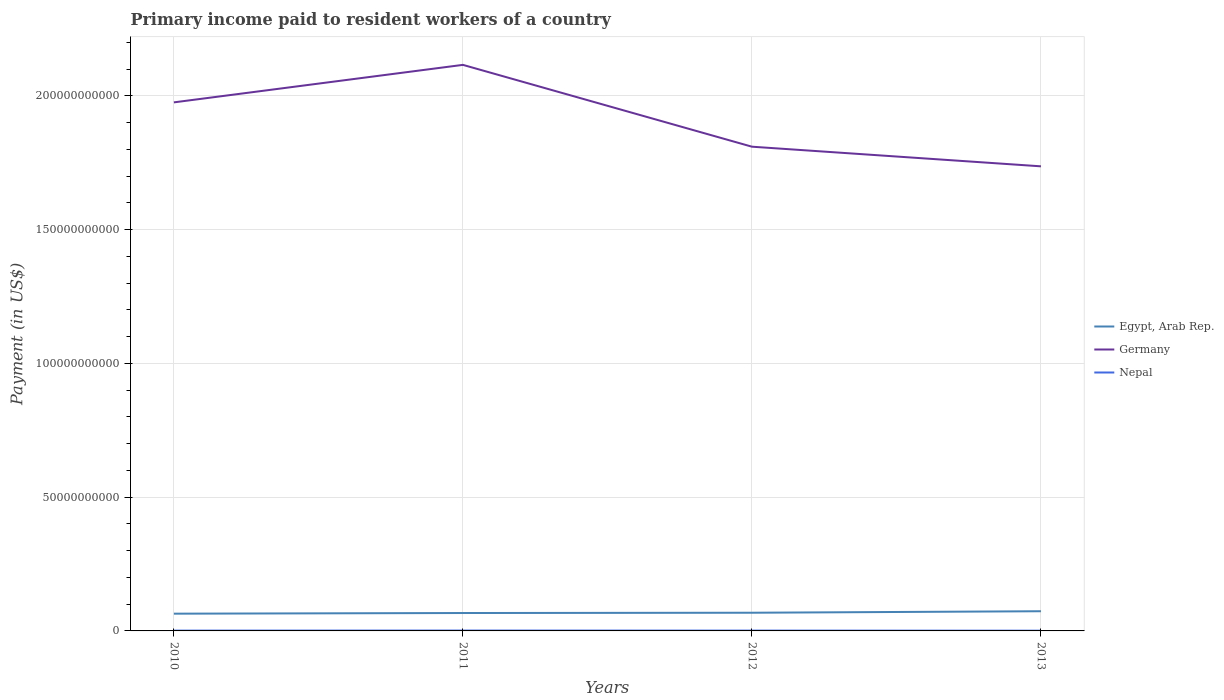How many different coloured lines are there?
Ensure brevity in your answer.  3. Across all years, what is the maximum amount paid to workers in Nepal?
Give a very brief answer. 9.06e+07. What is the total amount paid to workers in Egypt, Arab Rep. in the graph?
Provide a short and direct response. -1.01e+08. What is the difference between the highest and the second highest amount paid to workers in Egypt, Arab Rep.?
Give a very brief answer. 9.14e+08. What is the difference between the highest and the lowest amount paid to workers in Egypt, Arab Rep.?
Your answer should be very brief. 1. How many lines are there?
Keep it short and to the point. 3. What is the difference between two consecutive major ticks on the Y-axis?
Offer a terse response. 5.00e+1. Are the values on the major ticks of Y-axis written in scientific E-notation?
Provide a short and direct response. No. Does the graph contain grids?
Keep it short and to the point. Yes. Where does the legend appear in the graph?
Your response must be concise. Center right. What is the title of the graph?
Offer a very short reply. Primary income paid to resident workers of a country. Does "Namibia" appear as one of the legend labels in the graph?
Make the answer very short. No. What is the label or title of the X-axis?
Provide a succinct answer. Years. What is the label or title of the Y-axis?
Ensure brevity in your answer.  Payment (in US$). What is the Payment (in US$) in Egypt, Arab Rep. in 2010?
Offer a terse response. 6.45e+09. What is the Payment (in US$) in Germany in 2010?
Give a very brief answer. 1.98e+11. What is the Payment (in US$) in Nepal in 2010?
Provide a succinct answer. 1.16e+08. What is the Payment (in US$) of Egypt, Arab Rep. in 2011?
Offer a terse response. 6.69e+09. What is the Payment (in US$) in Germany in 2011?
Make the answer very short. 2.12e+11. What is the Payment (in US$) in Nepal in 2011?
Provide a short and direct response. 1.40e+08. What is the Payment (in US$) of Egypt, Arab Rep. in 2012?
Offer a terse response. 6.80e+09. What is the Payment (in US$) of Germany in 2012?
Offer a terse response. 1.81e+11. What is the Payment (in US$) of Nepal in 2012?
Provide a succinct answer. 1.22e+08. What is the Payment (in US$) in Egypt, Arab Rep. in 2013?
Your response must be concise. 7.36e+09. What is the Payment (in US$) in Germany in 2013?
Your answer should be very brief. 1.74e+11. What is the Payment (in US$) in Nepal in 2013?
Make the answer very short. 9.06e+07. Across all years, what is the maximum Payment (in US$) of Egypt, Arab Rep.?
Keep it short and to the point. 7.36e+09. Across all years, what is the maximum Payment (in US$) of Germany?
Offer a very short reply. 2.12e+11. Across all years, what is the maximum Payment (in US$) in Nepal?
Your answer should be very brief. 1.40e+08. Across all years, what is the minimum Payment (in US$) of Egypt, Arab Rep.?
Provide a succinct answer. 6.45e+09. Across all years, what is the minimum Payment (in US$) of Germany?
Your answer should be very brief. 1.74e+11. Across all years, what is the minimum Payment (in US$) of Nepal?
Keep it short and to the point. 9.06e+07. What is the total Payment (in US$) in Egypt, Arab Rep. in the graph?
Your answer should be very brief. 2.73e+1. What is the total Payment (in US$) in Germany in the graph?
Your answer should be compact. 7.64e+11. What is the total Payment (in US$) of Nepal in the graph?
Your response must be concise. 4.69e+08. What is the difference between the Payment (in US$) in Egypt, Arab Rep. in 2010 and that in 2011?
Keep it short and to the point. -2.49e+08. What is the difference between the Payment (in US$) in Germany in 2010 and that in 2011?
Offer a very short reply. -1.40e+1. What is the difference between the Payment (in US$) of Nepal in 2010 and that in 2011?
Make the answer very short. -2.42e+07. What is the difference between the Payment (in US$) of Egypt, Arab Rep. in 2010 and that in 2012?
Keep it short and to the point. -3.51e+08. What is the difference between the Payment (in US$) in Germany in 2010 and that in 2012?
Your answer should be very brief. 1.66e+1. What is the difference between the Payment (in US$) in Nepal in 2010 and that in 2012?
Provide a short and direct response. -5.85e+06. What is the difference between the Payment (in US$) in Egypt, Arab Rep. in 2010 and that in 2013?
Keep it short and to the point. -9.14e+08. What is the difference between the Payment (in US$) of Germany in 2010 and that in 2013?
Keep it short and to the point. 2.39e+1. What is the difference between the Payment (in US$) in Nepal in 2010 and that in 2013?
Offer a terse response. 2.55e+07. What is the difference between the Payment (in US$) of Egypt, Arab Rep. in 2011 and that in 2012?
Keep it short and to the point. -1.01e+08. What is the difference between the Payment (in US$) of Germany in 2011 and that in 2012?
Provide a short and direct response. 3.06e+1. What is the difference between the Payment (in US$) in Nepal in 2011 and that in 2012?
Your answer should be very brief. 1.84e+07. What is the difference between the Payment (in US$) in Egypt, Arab Rep. in 2011 and that in 2013?
Ensure brevity in your answer.  -6.65e+08. What is the difference between the Payment (in US$) of Germany in 2011 and that in 2013?
Keep it short and to the point. 3.79e+1. What is the difference between the Payment (in US$) in Nepal in 2011 and that in 2013?
Your answer should be compact. 4.97e+07. What is the difference between the Payment (in US$) of Egypt, Arab Rep. in 2012 and that in 2013?
Provide a short and direct response. -5.64e+08. What is the difference between the Payment (in US$) in Germany in 2012 and that in 2013?
Give a very brief answer. 7.34e+09. What is the difference between the Payment (in US$) of Nepal in 2012 and that in 2013?
Keep it short and to the point. 3.13e+07. What is the difference between the Payment (in US$) in Egypt, Arab Rep. in 2010 and the Payment (in US$) in Germany in 2011?
Make the answer very short. -2.05e+11. What is the difference between the Payment (in US$) in Egypt, Arab Rep. in 2010 and the Payment (in US$) in Nepal in 2011?
Offer a terse response. 6.31e+09. What is the difference between the Payment (in US$) of Germany in 2010 and the Payment (in US$) of Nepal in 2011?
Offer a very short reply. 1.97e+11. What is the difference between the Payment (in US$) of Egypt, Arab Rep. in 2010 and the Payment (in US$) of Germany in 2012?
Provide a succinct answer. -1.75e+11. What is the difference between the Payment (in US$) in Egypt, Arab Rep. in 2010 and the Payment (in US$) in Nepal in 2012?
Offer a terse response. 6.32e+09. What is the difference between the Payment (in US$) in Germany in 2010 and the Payment (in US$) in Nepal in 2012?
Ensure brevity in your answer.  1.97e+11. What is the difference between the Payment (in US$) in Egypt, Arab Rep. in 2010 and the Payment (in US$) in Germany in 2013?
Your answer should be very brief. -1.67e+11. What is the difference between the Payment (in US$) in Egypt, Arab Rep. in 2010 and the Payment (in US$) in Nepal in 2013?
Your response must be concise. 6.35e+09. What is the difference between the Payment (in US$) in Germany in 2010 and the Payment (in US$) in Nepal in 2013?
Offer a terse response. 1.97e+11. What is the difference between the Payment (in US$) in Egypt, Arab Rep. in 2011 and the Payment (in US$) in Germany in 2012?
Give a very brief answer. -1.74e+11. What is the difference between the Payment (in US$) in Egypt, Arab Rep. in 2011 and the Payment (in US$) in Nepal in 2012?
Ensure brevity in your answer.  6.57e+09. What is the difference between the Payment (in US$) in Germany in 2011 and the Payment (in US$) in Nepal in 2012?
Provide a short and direct response. 2.11e+11. What is the difference between the Payment (in US$) of Egypt, Arab Rep. in 2011 and the Payment (in US$) of Germany in 2013?
Your answer should be very brief. -1.67e+11. What is the difference between the Payment (in US$) in Egypt, Arab Rep. in 2011 and the Payment (in US$) in Nepal in 2013?
Provide a succinct answer. 6.60e+09. What is the difference between the Payment (in US$) of Germany in 2011 and the Payment (in US$) of Nepal in 2013?
Your answer should be very brief. 2.11e+11. What is the difference between the Payment (in US$) in Egypt, Arab Rep. in 2012 and the Payment (in US$) in Germany in 2013?
Keep it short and to the point. -1.67e+11. What is the difference between the Payment (in US$) of Egypt, Arab Rep. in 2012 and the Payment (in US$) of Nepal in 2013?
Your answer should be compact. 6.71e+09. What is the difference between the Payment (in US$) in Germany in 2012 and the Payment (in US$) in Nepal in 2013?
Provide a short and direct response. 1.81e+11. What is the average Payment (in US$) in Egypt, Arab Rep. per year?
Provide a short and direct response. 6.82e+09. What is the average Payment (in US$) of Germany per year?
Ensure brevity in your answer.  1.91e+11. What is the average Payment (in US$) of Nepal per year?
Your response must be concise. 1.17e+08. In the year 2010, what is the difference between the Payment (in US$) of Egypt, Arab Rep. and Payment (in US$) of Germany?
Ensure brevity in your answer.  -1.91e+11. In the year 2010, what is the difference between the Payment (in US$) in Egypt, Arab Rep. and Payment (in US$) in Nepal?
Ensure brevity in your answer.  6.33e+09. In the year 2010, what is the difference between the Payment (in US$) in Germany and Payment (in US$) in Nepal?
Your answer should be compact. 1.97e+11. In the year 2011, what is the difference between the Payment (in US$) of Egypt, Arab Rep. and Payment (in US$) of Germany?
Offer a very short reply. -2.05e+11. In the year 2011, what is the difference between the Payment (in US$) of Egypt, Arab Rep. and Payment (in US$) of Nepal?
Give a very brief answer. 6.55e+09. In the year 2011, what is the difference between the Payment (in US$) of Germany and Payment (in US$) of Nepal?
Provide a short and direct response. 2.11e+11. In the year 2012, what is the difference between the Payment (in US$) in Egypt, Arab Rep. and Payment (in US$) in Germany?
Keep it short and to the point. -1.74e+11. In the year 2012, what is the difference between the Payment (in US$) of Egypt, Arab Rep. and Payment (in US$) of Nepal?
Make the answer very short. 6.67e+09. In the year 2012, what is the difference between the Payment (in US$) of Germany and Payment (in US$) of Nepal?
Provide a succinct answer. 1.81e+11. In the year 2013, what is the difference between the Payment (in US$) of Egypt, Arab Rep. and Payment (in US$) of Germany?
Provide a succinct answer. -1.66e+11. In the year 2013, what is the difference between the Payment (in US$) in Egypt, Arab Rep. and Payment (in US$) in Nepal?
Your answer should be compact. 7.27e+09. In the year 2013, what is the difference between the Payment (in US$) of Germany and Payment (in US$) of Nepal?
Offer a terse response. 1.74e+11. What is the ratio of the Payment (in US$) in Egypt, Arab Rep. in 2010 to that in 2011?
Make the answer very short. 0.96. What is the ratio of the Payment (in US$) in Germany in 2010 to that in 2011?
Make the answer very short. 0.93. What is the ratio of the Payment (in US$) in Nepal in 2010 to that in 2011?
Make the answer very short. 0.83. What is the ratio of the Payment (in US$) in Egypt, Arab Rep. in 2010 to that in 2012?
Your answer should be very brief. 0.95. What is the ratio of the Payment (in US$) of Germany in 2010 to that in 2012?
Your answer should be compact. 1.09. What is the ratio of the Payment (in US$) in Egypt, Arab Rep. in 2010 to that in 2013?
Your answer should be compact. 0.88. What is the ratio of the Payment (in US$) of Germany in 2010 to that in 2013?
Offer a very short reply. 1.14. What is the ratio of the Payment (in US$) in Nepal in 2010 to that in 2013?
Provide a short and direct response. 1.28. What is the ratio of the Payment (in US$) of Egypt, Arab Rep. in 2011 to that in 2012?
Provide a short and direct response. 0.99. What is the ratio of the Payment (in US$) of Germany in 2011 to that in 2012?
Provide a succinct answer. 1.17. What is the ratio of the Payment (in US$) in Nepal in 2011 to that in 2012?
Provide a short and direct response. 1.15. What is the ratio of the Payment (in US$) of Egypt, Arab Rep. in 2011 to that in 2013?
Provide a succinct answer. 0.91. What is the ratio of the Payment (in US$) of Germany in 2011 to that in 2013?
Offer a very short reply. 1.22. What is the ratio of the Payment (in US$) in Nepal in 2011 to that in 2013?
Your answer should be very brief. 1.55. What is the ratio of the Payment (in US$) in Egypt, Arab Rep. in 2012 to that in 2013?
Give a very brief answer. 0.92. What is the ratio of the Payment (in US$) in Germany in 2012 to that in 2013?
Your response must be concise. 1.04. What is the ratio of the Payment (in US$) in Nepal in 2012 to that in 2013?
Offer a very short reply. 1.35. What is the difference between the highest and the second highest Payment (in US$) of Egypt, Arab Rep.?
Provide a short and direct response. 5.64e+08. What is the difference between the highest and the second highest Payment (in US$) of Germany?
Ensure brevity in your answer.  1.40e+1. What is the difference between the highest and the second highest Payment (in US$) in Nepal?
Provide a short and direct response. 1.84e+07. What is the difference between the highest and the lowest Payment (in US$) in Egypt, Arab Rep.?
Offer a very short reply. 9.14e+08. What is the difference between the highest and the lowest Payment (in US$) in Germany?
Give a very brief answer. 3.79e+1. What is the difference between the highest and the lowest Payment (in US$) in Nepal?
Offer a very short reply. 4.97e+07. 